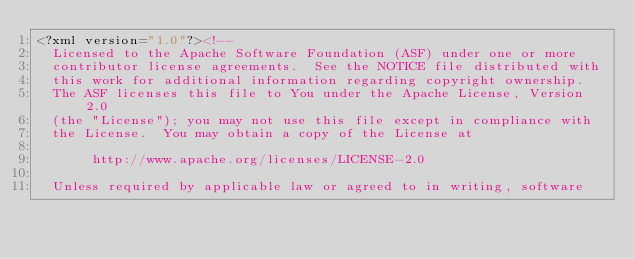<code> <loc_0><loc_0><loc_500><loc_500><_XML_><?xml version="1.0"?><!--
  Licensed to the Apache Software Foundation (ASF) under one or more
  contributor license agreements.  See the NOTICE file distributed with
  this work for additional information regarding copyright ownership.
  The ASF licenses this file to You under the Apache License, Version 2.0
  (the "License"); you may not use this file except in compliance with
  the License.  You may obtain a copy of the License at

       http://www.apache.org/licenses/LICENSE-2.0

  Unless required by applicable law or agreed to in writing, software</code> 